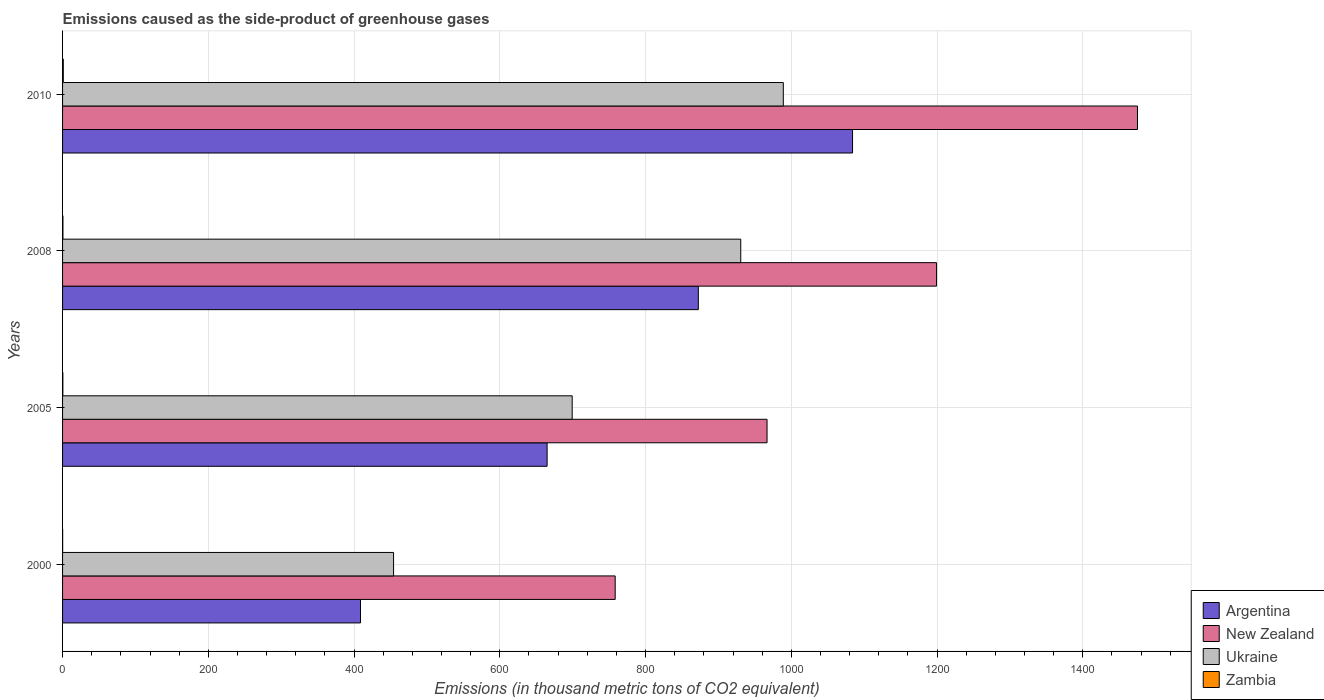Are the number of bars per tick equal to the number of legend labels?
Give a very brief answer. Yes. How many bars are there on the 1st tick from the bottom?
Your answer should be very brief. 4. Across all years, what is the maximum emissions caused as the side-product of greenhouse gases in Argentina?
Your answer should be very brief. 1084. Across all years, what is the minimum emissions caused as the side-product of greenhouse gases in New Zealand?
Your answer should be compact. 758.3. In which year was the emissions caused as the side-product of greenhouse gases in Ukraine maximum?
Make the answer very short. 2010. In which year was the emissions caused as the side-product of greenhouse gases in Argentina minimum?
Your response must be concise. 2000. What is the total emissions caused as the side-product of greenhouse gases in Argentina in the graph?
Offer a very short reply. 3030.1. What is the difference between the emissions caused as the side-product of greenhouse gases in Argentina in 2000 and that in 2008?
Your answer should be compact. -463.6. What is the difference between the emissions caused as the side-product of greenhouse gases in Zambia in 2010 and the emissions caused as the side-product of greenhouse gases in New Zealand in 2005?
Ensure brevity in your answer.  -965.7. What is the average emissions caused as the side-product of greenhouse gases in Ukraine per year?
Ensure brevity in your answer.  768.27. In the year 2005, what is the difference between the emissions caused as the side-product of greenhouse gases in Argentina and emissions caused as the side-product of greenhouse gases in Ukraine?
Keep it short and to the point. -34.4. In how many years, is the emissions caused as the side-product of greenhouse gases in Ukraine greater than 1120 thousand metric tons?
Provide a succinct answer. 0. What is the ratio of the emissions caused as the side-product of greenhouse gases in Zambia in 2008 to that in 2010?
Provide a succinct answer. 0.5. Is the difference between the emissions caused as the side-product of greenhouse gases in Argentina in 2005 and 2008 greater than the difference between the emissions caused as the side-product of greenhouse gases in Ukraine in 2005 and 2008?
Ensure brevity in your answer.  Yes. What is the difference between the highest and the second highest emissions caused as the side-product of greenhouse gases in New Zealand?
Give a very brief answer. 275.7. What is the difference between the highest and the lowest emissions caused as the side-product of greenhouse gases in Ukraine?
Offer a very short reply. 534.8. Is the sum of the emissions caused as the side-product of greenhouse gases in New Zealand in 2000 and 2005 greater than the maximum emissions caused as the side-product of greenhouse gases in Argentina across all years?
Keep it short and to the point. Yes. What does the 2nd bar from the top in 2008 represents?
Your response must be concise. Ukraine. What does the 1st bar from the bottom in 2005 represents?
Ensure brevity in your answer.  Argentina. Are all the bars in the graph horizontal?
Your answer should be very brief. Yes. What is the difference between two consecutive major ticks on the X-axis?
Your response must be concise. 200. Are the values on the major ticks of X-axis written in scientific E-notation?
Offer a very short reply. No. Does the graph contain grids?
Give a very brief answer. Yes. Where does the legend appear in the graph?
Give a very brief answer. Bottom right. How many legend labels are there?
Make the answer very short. 4. How are the legend labels stacked?
Offer a terse response. Vertical. What is the title of the graph?
Your answer should be compact. Emissions caused as the side-product of greenhouse gases. Does "Denmark" appear as one of the legend labels in the graph?
Offer a terse response. No. What is the label or title of the X-axis?
Provide a short and direct response. Emissions (in thousand metric tons of CO2 equivalent). What is the Emissions (in thousand metric tons of CO2 equivalent) in Argentina in 2000?
Keep it short and to the point. 408.8. What is the Emissions (in thousand metric tons of CO2 equivalent) in New Zealand in 2000?
Your response must be concise. 758.3. What is the Emissions (in thousand metric tons of CO2 equivalent) of Ukraine in 2000?
Your answer should be compact. 454.2. What is the Emissions (in thousand metric tons of CO2 equivalent) of Argentina in 2005?
Keep it short and to the point. 664.9. What is the Emissions (in thousand metric tons of CO2 equivalent) in New Zealand in 2005?
Provide a short and direct response. 966.7. What is the Emissions (in thousand metric tons of CO2 equivalent) of Ukraine in 2005?
Your response must be concise. 699.3. What is the Emissions (in thousand metric tons of CO2 equivalent) of Argentina in 2008?
Offer a terse response. 872.4. What is the Emissions (in thousand metric tons of CO2 equivalent) in New Zealand in 2008?
Make the answer very short. 1199.3. What is the Emissions (in thousand metric tons of CO2 equivalent) in Ukraine in 2008?
Offer a terse response. 930.6. What is the Emissions (in thousand metric tons of CO2 equivalent) of Zambia in 2008?
Offer a terse response. 0.5. What is the Emissions (in thousand metric tons of CO2 equivalent) in Argentina in 2010?
Your answer should be very brief. 1084. What is the Emissions (in thousand metric tons of CO2 equivalent) in New Zealand in 2010?
Your answer should be very brief. 1475. What is the Emissions (in thousand metric tons of CO2 equivalent) in Ukraine in 2010?
Offer a very short reply. 989. What is the Emissions (in thousand metric tons of CO2 equivalent) of Zambia in 2010?
Make the answer very short. 1. Across all years, what is the maximum Emissions (in thousand metric tons of CO2 equivalent) in Argentina?
Your answer should be very brief. 1084. Across all years, what is the maximum Emissions (in thousand metric tons of CO2 equivalent) of New Zealand?
Provide a succinct answer. 1475. Across all years, what is the maximum Emissions (in thousand metric tons of CO2 equivalent) of Ukraine?
Offer a terse response. 989. Across all years, what is the maximum Emissions (in thousand metric tons of CO2 equivalent) in Zambia?
Provide a succinct answer. 1. Across all years, what is the minimum Emissions (in thousand metric tons of CO2 equivalent) in Argentina?
Your answer should be compact. 408.8. Across all years, what is the minimum Emissions (in thousand metric tons of CO2 equivalent) of New Zealand?
Keep it short and to the point. 758.3. Across all years, what is the minimum Emissions (in thousand metric tons of CO2 equivalent) of Ukraine?
Your answer should be very brief. 454.2. What is the total Emissions (in thousand metric tons of CO2 equivalent) of Argentina in the graph?
Give a very brief answer. 3030.1. What is the total Emissions (in thousand metric tons of CO2 equivalent) of New Zealand in the graph?
Provide a succinct answer. 4399.3. What is the total Emissions (in thousand metric tons of CO2 equivalent) of Ukraine in the graph?
Offer a very short reply. 3073.1. What is the total Emissions (in thousand metric tons of CO2 equivalent) in Zambia in the graph?
Provide a succinct answer. 2. What is the difference between the Emissions (in thousand metric tons of CO2 equivalent) in Argentina in 2000 and that in 2005?
Your response must be concise. -256.1. What is the difference between the Emissions (in thousand metric tons of CO2 equivalent) in New Zealand in 2000 and that in 2005?
Provide a succinct answer. -208.4. What is the difference between the Emissions (in thousand metric tons of CO2 equivalent) in Ukraine in 2000 and that in 2005?
Your response must be concise. -245.1. What is the difference between the Emissions (in thousand metric tons of CO2 equivalent) of Argentina in 2000 and that in 2008?
Provide a succinct answer. -463.6. What is the difference between the Emissions (in thousand metric tons of CO2 equivalent) in New Zealand in 2000 and that in 2008?
Your response must be concise. -441. What is the difference between the Emissions (in thousand metric tons of CO2 equivalent) of Ukraine in 2000 and that in 2008?
Give a very brief answer. -476.4. What is the difference between the Emissions (in thousand metric tons of CO2 equivalent) in Zambia in 2000 and that in 2008?
Offer a terse response. -0.4. What is the difference between the Emissions (in thousand metric tons of CO2 equivalent) of Argentina in 2000 and that in 2010?
Provide a short and direct response. -675.2. What is the difference between the Emissions (in thousand metric tons of CO2 equivalent) in New Zealand in 2000 and that in 2010?
Offer a terse response. -716.7. What is the difference between the Emissions (in thousand metric tons of CO2 equivalent) in Ukraine in 2000 and that in 2010?
Provide a succinct answer. -534.8. What is the difference between the Emissions (in thousand metric tons of CO2 equivalent) of Zambia in 2000 and that in 2010?
Provide a short and direct response. -0.9. What is the difference between the Emissions (in thousand metric tons of CO2 equivalent) in Argentina in 2005 and that in 2008?
Keep it short and to the point. -207.5. What is the difference between the Emissions (in thousand metric tons of CO2 equivalent) of New Zealand in 2005 and that in 2008?
Offer a terse response. -232.6. What is the difference between the Emissions (in thousand metric tons of CO2 equivalent) of Ukraine in 2005 and that in 2008?
Provide a short and direct response. -231.3. What is the difference between the Emissions (in thousand metric tons of CO2 equivalent) in Argentina in 2005 and that in 2010?
Keep it short and to the point. -419.1. What is the difference between the Emissions (in thousand metric tons of CO2 equivalent) in New Zealand in 2005 and that in 2010?
Your answer should be compact. -508.3. What is the difference between the Emissions (in thousand metric tons of CO2 equivalent) of Ukraine in 2005 and that in 2010?
Make the answer very short. -289.7. What is the difference between the Emissions (in thousand metric tons of CO2 equivalent) of Argentina in 2008 and that in 2010?
Make the answer very short. -211.6. What is the difference between the Emissions (in thousand metric tons of CO2 equivalent) in New Zealand in 2008 and that in 2010?
Offer a very short reply. -275.7. What is the difference between the Emissions (in thousand metric tons of CO2 equivalent) in Ukraine in 2008 and that in 2010?
Provide a short and direct response. -58.4. What is the difference between the Emissions (in thousand metric tons of CO2 equivalent) of Zambia in 2008 and that in 2010?
Offer a very short reply. -0.5. What is the difference between the Emissions (in thousand metric tons of CO2 equivalent) of Argentina in 2000 and the Emissions (in thousand metric tons of CO2 equivalent) of New Zealand in 2005?
Your answer should be very brief. -557.9. What is the difference between the Emissions (in thousand metric tons of CO2 equivalent) of Argentina in 2000 and the Emissions (in thousand metric tons of CO2 equivalent) of Ukraine in 2005?
Your response must be concise. -290.5. What is the difference between the Emissions (in thousand metric tons of CO2 equivalent) of Argentina in 2000 and the Emissions (in thousand metric tons of CO2 equivalent) of Zambia in 2005?
Your answer should be very brief. 408.4. What is the difference between the Emissions (in thousand metric tons of CO2 equivalent) in New Zealand in 2000 and the Emissions (in thousand metric tons of CO2 equivalent) in Ukraine in 2005?
Provide a succinct answer. 59. What is the difference between the Emissions (in thousand metric tons of CO2 equivalent) in New Zealand in 2000 and the Emissions (in thousand metric tons of CO2 equivalent) in Zambia in 2005?
Give a very brief answer. 757.9. What is the difference between the Emissions (in thousand metric tons of CO2 equivalent) of Ukraine in 2000 and the Emissions (in thousand metric tons of CO2 equivalent) of Zambia in 2005?
Keep it short and to the point. 453.8. What is the difference between the Emissions (in thousand metric tons of CO2 equivalent) of Argentina in 2000 and the Emissions (in thousand metric tons of CO2 equivalent) of New Zealand in 2008?
Your response must be concise. -790.5. What is the difference between the Emissions (in thousand metric tons of CO2 equivalent) in Argentina in 2000 and the Emissions (in thousand metric tons of CO2 equivalent) in Ukraine in 2008?
Provide a short and direct response. -521.8. What is the difference between the Emissions (in thousand metric tons of CO2 equivalent) of Argentina in 2000 and the Emissions (in thousand metric tons of CO2 equivalent) of Zambia in 2008?
Your response must be concise. 408.3. What is the difference between the Emissions (in thousand metric tons of CO2 equivalent) of New Zealand in 2000 and the Emissions (in thousand metric tons of CO2 equivalent) of Ukraine in 2008?
Keep it short and to the point. -172.3. What is the difference between the Emissions (in thousand metric tons of CO2 equivalent) of New Zealand in 2000 and the Emissions (in thousand metric tons of CO2 equivalent) of Zambia in 2008?
Provide a succinct answer. 757.8. What is the difference between the Emissions (in thousand metric tons of CO2 equivalent) of Ukraine in 2000 and the Emissions (in thousand metric tons of CO2 equivalent) of Zambia in 2008?
Ensure brevity in your answer.  453.7. What is the difference between the Emissions (in thousand metric tons of CO2 equivalent) of Argentina in 2000 and the Emissions (in thousand metric tons of CO2 equivalent) of New Zealand in 2010?
Make the answer very short. -1066.2. What is the difference between the Emissions (in thousand metric tons of CO2 equivalent) in Argentina in 2000 and the Emissions (in thousand metric tons of CO2 equivalent) in Ukraine in 2010?
Keep it short and to the point. -580.2. What is the difference between the Emissions (in thousand metric tons of CO2 equivalent) in Argentina in 2000 and the Emissions (in thousand metric tons of CO2 equivalent) in Zambia in 2010?
Offer a terse response. 407.8. What is the difference between the Emissions (in thousand metric tons of CO2 equivalent) of New Zealand in 2000 and the Emissions (in thousand metric tons of CO2 equivalent) of Ukraine in 2010?
Your answer should be very brief. -230.7. What is the difference between the Emissions (in thousand metric tons of CO2 equivalent) of New Zealand in 2000 and the Emissions (in thousand metric tons of CO2 equivalent) of Zambia in 2010?
Offer a very short reply. 757.3. What is the difference between the Emissions (in thousand metric tons of CO2 equivalent) in Ukraine in 2000 and the Emissions (in thousand metric tons of CO2 equivalent) in Zambia in 2010?
Give a very brief answer. 453.2. What is the difference between the Emissions (in thousand metric tons of CO2 equivalent) in Argentina in 2005 and the Emissions (in thousand metric tons of CO2 equivalent) in New Zealand in 2008?
Make the answer very short. -534.4. What is the difference between the Emissions (in thousand metric tons of CO2 equivalent) in Argentina in 2005 and the Emissions (in thousand metric tons of CO2 equivalent) in Ukraine in 2008?
Offer a very short reply. -265.7. What is the difference between the Emissions (in thousand metric tons of CO2 equivalent) in Argentina in 2005 and the Emissions (in thousand metric tons of CO2 equivalent) in Zambia in 2008?
Offer a terse response. 664.4. What is the difference between the Emissions (in thousand metric tons of CO2 equivalent) in New Zealand in 2005 and the Emissions (in thousand metric tons of CO2 equivalent) in Ukraine in 2008?
Your response must be concise. 36.1. What is the difference between the Emissions (in thousand metric tons of CO2 equivalent) of New Zealand in 2005 and the Emissions (in thousand metric tons of CO2 equivalent) of Zambia in 2008?
Your response must be concise. 966.2. What is the difference between the Emissions (in thousand metric tons of CO2 equivalent) of Ukraine in 2005 and the Emissions (in thousand metric tons of CO2 equivalent) of Zambia in 2008?
Give a very brief answer. 698.8. What is the difference between the Emissions (in thousand metric tons of CO2 equivalent) in Argentina in 2005 and the Emissions (in thousand metric tons of CO2 equivalent) in New Zealand in 2010?
Your answer should be very brief. -810.1. What is the difference between the Emissions (in thousand metric tons of CO2 equivalent) in Argentina in 2005 and the Emissions (in thousand metric tons of CO2 equivalent) in Ukraine in 2010?
Your answer should be very brief. -324.1. What is the difference between the Emissions (in thousand metric tons of CO2 equivalent) in Argentina in 2005 and the Emissions (in thousand metric tons of CO2 equivalent) in Zambia in 2010?
Provide a succinct answer. 663.9. What is the difference between the Emissions (in thousand metric tons of CO2 equivalent) in New Zealand in 2005 and the Emissions (in thousand metric tons of CO2 equivalent) in Ukraine in 2010?
Your answer should be compact. -22.3. What is the difference between the Emissions (in thousand metric tons of CO2 equivalent) of New Zealand in 2005 and the Emissions (in thousand metric tons of CO2 equivalent) of Zambia in 2010?
Give a very brief answer. 965.7. What is the difference between the Emissions (in thousand metric tons of CO2 equivalent) in Ukraine in 2005 and the Emissions (in thousand metric tons of CO2 equivalent) in Zambia in 2010?
Your answer should be very brief. 698.3. What is the difference between the Emissions (in thousand metric tons of CO2 equivalent) of Argentina in 2008 and the Emissions (in thousand metric tons of CO2 equivalent) of New Zealand in 2010?
Provide a succinct answer. -602.6. What is the difference between the Emissions (in thousand metric tons of CO2 equivalent) in Argentina in 2008 and the Emissions (in thousand metric tons of CO2 equivalent) in Ukraine in 2010?
Your answer should be very brief. -116.6. What is the difference between the Emissions (in thousand metric tons of CO2 equivalent) of Argentina in 2008 and the Emissions (in thousand metric tons of CO2 equivalent) of Zambia in 2010?
Your response must be concise. 871.4. What is the difference between the Emissions (in thousand metric tons of CO2 equivalent) in New Zealand in 2008 and the Emissions (in thousand metric tons of CO2 equivalent) in Ukraine in 2010?
Offer a terse response. 210.3. What is the difference between the Emissions (in thousand metric tons of CO2 equivalent) of New Zealand in 2008 and the Emissions (in thousand metric tons of CO2 equivalent) of Zambia in 2010?
Provide a short and direct response. 1198.3. What is the difference between the Emissions (in thousand metric tons of CO2 equivalent) of Ukraine in 2008 and the Emissions (in thousand metric tons of CO2 equivalent) of Zambia in 2010?
Give a very brief answer. 929.6. What is the average Emissions (in thousand metric tons of CO2 equivalent) in Argentina per year?
Provide a short and direct response. 757.52. What is the average Emissions (in thousand metric tons of CO2 equivalent) of New Zealand per year?
Offer a terse response. 1099.83. What is the average Emissions (in thousand metric tons of CO2 equivalent) of Ukraine per year?
Give a very brief answer. 768.27. What is the average Emissions (in thousand metric tons of CO2 equivalent) in Zambia per year?
Your answer should be compact. 0.5. In the year 2000, what is the difference between the Emissions (in thousand metric tons of CO2 equivalent) in Argentina and Emissions (in thousand metric tons of CO2 equivalent) in New Zealand?
Offer a very short reply. -349.5. In the year 2000, what is the difference between the Emissions (in thousand metric tons of CO2 equivalent) in Argentina and Emissions (in thousand metric tons of CO2 equivalent) in Ukraine?
Provide a short and direct response. -45.4. In the year 2000, what is the difference between the Emissions (in thousand metric tons of CO2 equivalent) of Argentina and Emissions (in thousand metric tons of CO2 equivalent) of Zambia?
Ensure brevity in your answer.  408.7. In the year 2000, what is the difference between the Emissions (in thousand metric tons of CO2 equivalent) of New Zealand and Emissions (in thousand metric tons of CO2 equivalent) of Ukraine?
Your response must be concise. 304.1. In the year 2000, what is the difference between the Emissions (in thousand metric tons of CO2 equivalent) of New Zealand and Emissions (in thousand metric tons of CO2 equivalent) of Zambia?
Make the answer very short. 758.2. In the year 2000, what is the difference between the Emissions (in thousand metric tons of CO2 equivalent) in Ukraine and Emissions (in thousand metric tons of CO2 equivalent) in Zambia?
Your response must be concise. 454.1. In the year 2005, what is the difference between the Emissions (in thousand metric tons of CO2 equivalent) in Argentina and Emissions (in thousand metric tons of CO2 equivalent) in New Zealand?
Your response must be concise. -301.8. In the year 2005, what is the difference between the Emissions (in thousand metric tons of CO2 equivalent) in Argentina and Emissions (in thousand metric tons of CO2 equivalent) in Ukraine?
Ensure brevity in your answer.  -34.4. In the year 2005, what is the difference between the Emissions (in thousand metric tons of CO2 equivalent) in Argentina and Emissions (in thousand metric tons of CO2 equivalent) in Zambia?
Provide a succinct answer. 664.5. In the year 2005, what is the difference between the Emissions (in thousand metric tons of CO2 equivalent) of New Zealand and Emissions (in thousand metric tons of CO2 equivalent) of Ukraine?
Your answer should be compact. 267.4. In the year 2005, what is the difference between the Emissions (in thousand metric tons of CO2 equivalent) of New Zealand and Emissions (in thousand metric tons of CO2 equivalent) of Zambia?
Make the answer very short. 966.3. In the year 2005, what is the difference between the Emissions (in thousand metric tons of CO2 equivalent) of Ukraine and Emissions (in thousand metric tons of CO2 equivalent) of Zambia?
Your answer should be very brief. 698.9. In the year 2008, what is the difference between the Emissions (in thousand metric tons of CO2 equivalent) in Argentina and Emissions (in thousand metric tons of CO2 equivalent) in New Zealand?
Offer a very short reply. -326.9. In the year 2008, what is the difference between the Emissions (in thousand metric tons of CO2 equivalent) of Argentina and Emissions (in thousand metric tons of CO2 equivalent) of Ukraine?
Your response must be concise. -58.2. In the year 2008, what is the difference between the Emissions (in thousand metric tons of CO2 equivalent) in Argentina and Emissions (in thousand metric tons of CO2 equivalent) in Zambia?
Your answer should be compact. 871.9. In the year 2008, what is the difference between the Emissions (in thousand metric tons of CO2 equivalent) of New Zealand and Emissions (in thousand metric tons of CO2 equivalent) of Ukraine?
Keep it short and to the point. 268.7. In the year 2008, what is the difference between the Emissions (in thousand metric tons of CO2 equivalent) of New Zealand and Emissions (in thousand metric tons of CO2 equivalent) of Zambia?
Provide a succinct answer. 1198.8. In the year 2008, what is the difference between the Emissions (in thousand metric tons of CO2 equivalent) of Ukraine and Emissions (in thousand metric tons of CO2 equivalent) of Zambia?
Your answer should be compact. 930.1. In the year 2010, what is the difference between the Emissions (in thousand metric tons of CO2 equivalent) of Argentina and Emissions (in thousand metric tons of CO2 equivalent) of New Zealand?
Offer a very short reply. -391. In the year 2010, what is the difference between the Emissions (in thousand metric tons of CO2 equivalent) of Argentina and Emissions (in thousand metric tons of CO2 equivalent) of Ukraine?
Make the answer very short. 95. In the year 2010, what is the difference between the Emissions (in thousand metric tons of CO2 equivalent) of Argentina and Emissions (in thousand metric tons of CO2 equivalent) of Zambia?
Provide a short and direct response. 1083. In the year 2010, what is the difference between the Emissions (in thousand metric tons of CO2 equivalent) of New Zealand and Emissions (in thousand metric tons of CO2 equivalent) of Ukraine?
Your answer should be compact. 486. In the year 2010, what is the difference between the Emissions (in thousand metric tons of CO2 equivalent) in New Zealand and Emissions (in thousand metric tons of CO2 equivalent) in Zambia?
Ensure brevity in your answer.  1474. In the year 2010, what is the difference between the Emissions (in thousand metric tons of CO2 equivalent) in Ukraine and Emissions (in thousand metric tons of CO2 equivalent) in Zambia?
Keep it short and to the point. 988. What is the ratio of the Emissions (in thousand metric tons of CO2 equivalent) of Argentina in 2000 to that in 2005?
Ensure brevity in your answer.  0.61. What is the ratio of the Emissions (in thousand metric tons of CO2 equivalent) in New Zealand in 2000 to that in 2005?
Provide a short and direct response. 0.78. What is the ratio of the Emissions (in thousand metric tons of CO2 equivalent) of Ukraine in 2000 to that in 2005?
Offer a very short reply. 0.65. What is the ratio of the Emissions (in thousand metric tons of CO2 equivalent) of Zambia in 2000 to that in 2005?
Ensure brevity in your answer.  0.25. What is the ratio of the Emissions (in thousand metric tons of CO2 equivalent) of Argentina in 2000 to that in 2008?
Your answer should be very brief. 0.47. What is the ratio of the Emissions (in thousand metric tons of CO2 equivalent) of New Zealand in 2000 to that in 2008?
Your answer should be compact. 0.63. What is the ratio of the Emissions (in thousand metric tons of CO2 equivalent) in Ukraine in 2000 to that in 2008?
Provide a short and direct response. 0.49. What is the ratio of the Emissions (in thousand metric tons of CO2 equivalent) of Zambia in 2000 to that in 2008?
Offer a terse response. 0.2. What is the ratio of the Emissions (in thousand metric tons of CO2 equivalent) in Argentina in 2000 to that in 2010?
Provide a succinct answer. 0.38. What is the ratio of the Emissions (in thousand metric tons of CO2 equivalent) of New Zealand in 2000 to that in 2010?
Provide a succinct answer. 0.51. What is the ratio of the Emissions (in thousand metric tons of CO2 equivalent) in Ukraine in 2000 to that in 2010?
Your answer should be compact. 0.46. What is the ratio of the Emissions (in thousand metric tons of CO2 equivalent) in Argentina in 2005 to that in 2008?
Your answer should be very brief. 0.76. What is the ratio of the Emissions (in thousand metric tons of CO2 equivalent) in New Zealand in 2005 to that in 2008?
Offer a very short reply. 0.81. What is the ratio of the Emissions (in thousand metric tons of CO2 equivalent) in Ukraine in 2005 to that in 2008?
Offer a terse response. 0.75. What is the ratio of the Emissions (in thousand metric tons of CO2 equivalent) in Zambia in 2005 to that in 2008?
Offer a very short reply. 0.8. What is the ratio of the Emissions (in thousand metric tons of CO2 equivalent) in Argentina in 2005 to that in 2010?
Your answer should be compact. 0.61. What is the ratio of the Emissions (in thousand metric tons of CO2 equivalent) in New Zealand in 2005 to that in 2010?
Your answer should be compact. 0.66. What is the ratio of the Emissions (in thousand metric tons of CO2 equivalent) of Ukraine in 2005 to that in 2010?
Your response must be concise. 0.71. What is the ratio of the Emissions (in thousand metric tons of CO2 equivalent) in Zambia in 2005 to that in 2010?
Give a very brief answer. 0.4. What is the ratio of the Emissions (in thousand metric tons of CO2 equivalent) in Argentina in 2008 to that in 2010?
Offer a very short reply. 0.8. What is the ratio of the Emissions (in thousand metric tons of CO2 equivalent) in New Zealand in 2008 to that in 2010?
Offer a terse response. 0.81. What is the ratio of the Emissions (in thousand metric tons of CO2 equivalent) of Ukraine in 2008 to that in 2010?
Offer a terse response. 0.94. What is the difference between the highest and the second highest Emissions (in thousand metric tons of CO2 equivalent) of Argentina?
Provide a short and direct response. 211.6. What is the difference between the highest and the second highest Emissions (in thousand metric tons of CO2 equivalent) in New Zealand?
Offer a very short reply. 275.7. What is the difference between the highest and the second highest Emissions (in thousand metric tons of CO2 equivalent) of Ukraine?
Give a very brief answer. 58.4. What is the difference between the highest and the second highest Emissions (in thousand metric tons of CO2 equivalent) of Zambia?
Make the answer very short. 0.5. What is the difference between the highest and the lowest Emissions (in thousand metric tons of CO2 equivalent) of Argentina?
Make the answer very short. 675.2. What is the difference between the highest and the lowest Emissions (in thousand metric tons of CO2 equivalent) in New Zealand?
Provide a short and direct response. 716.7. What is the difference between the highest and the lowest Emissions (in thousand metric tons of CO2 equivalent) of Ukraine?
Your answer should be compact. 534.8. 